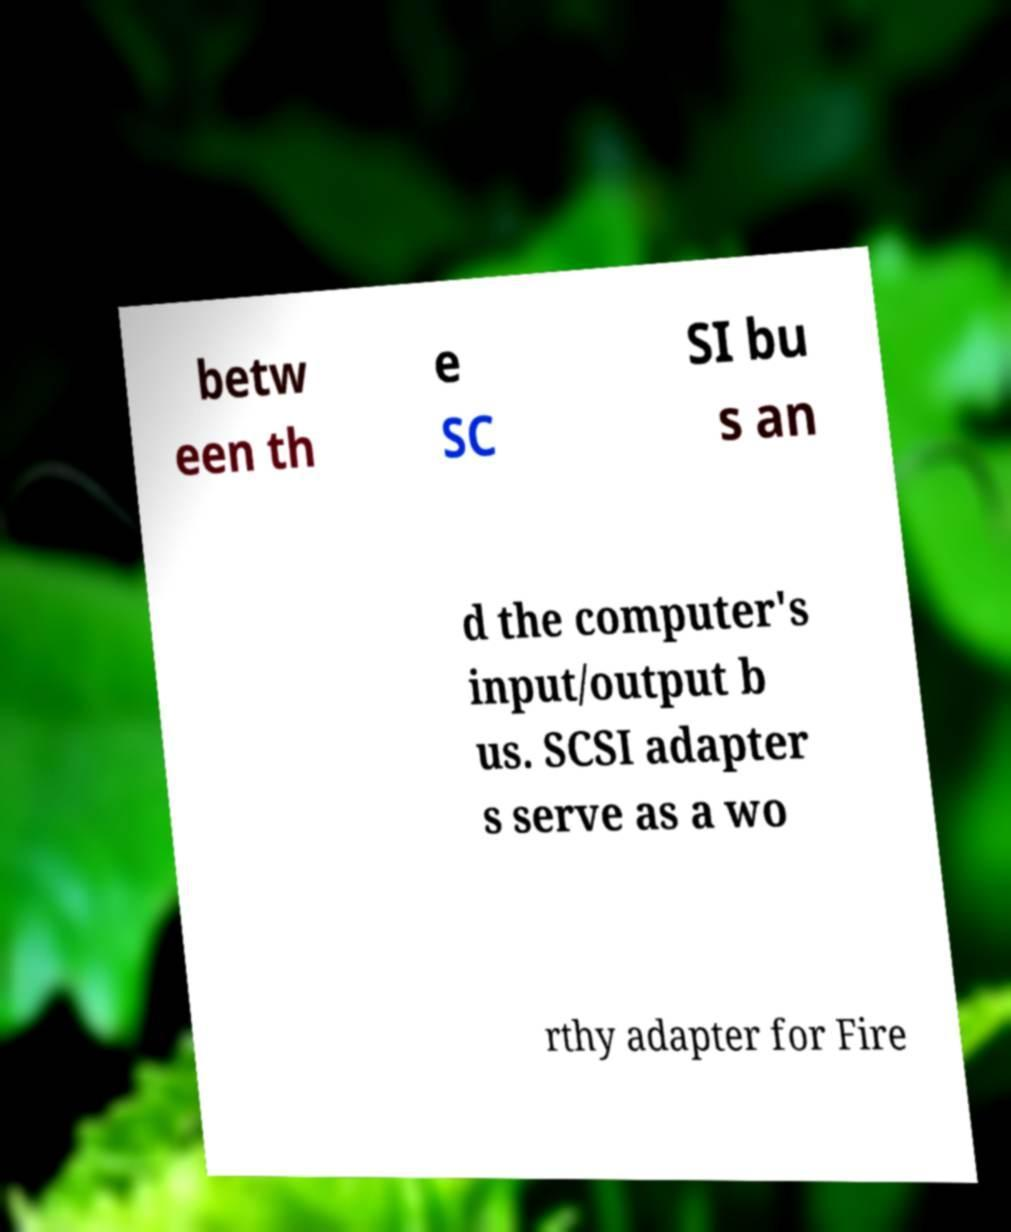Could you assist in decoding the text presented in this image and type it out clearly? betw een th e SC SI bu s an d the computer's input/output b us. SCSI adapter s serve as a wo rthy adapter for Fire 